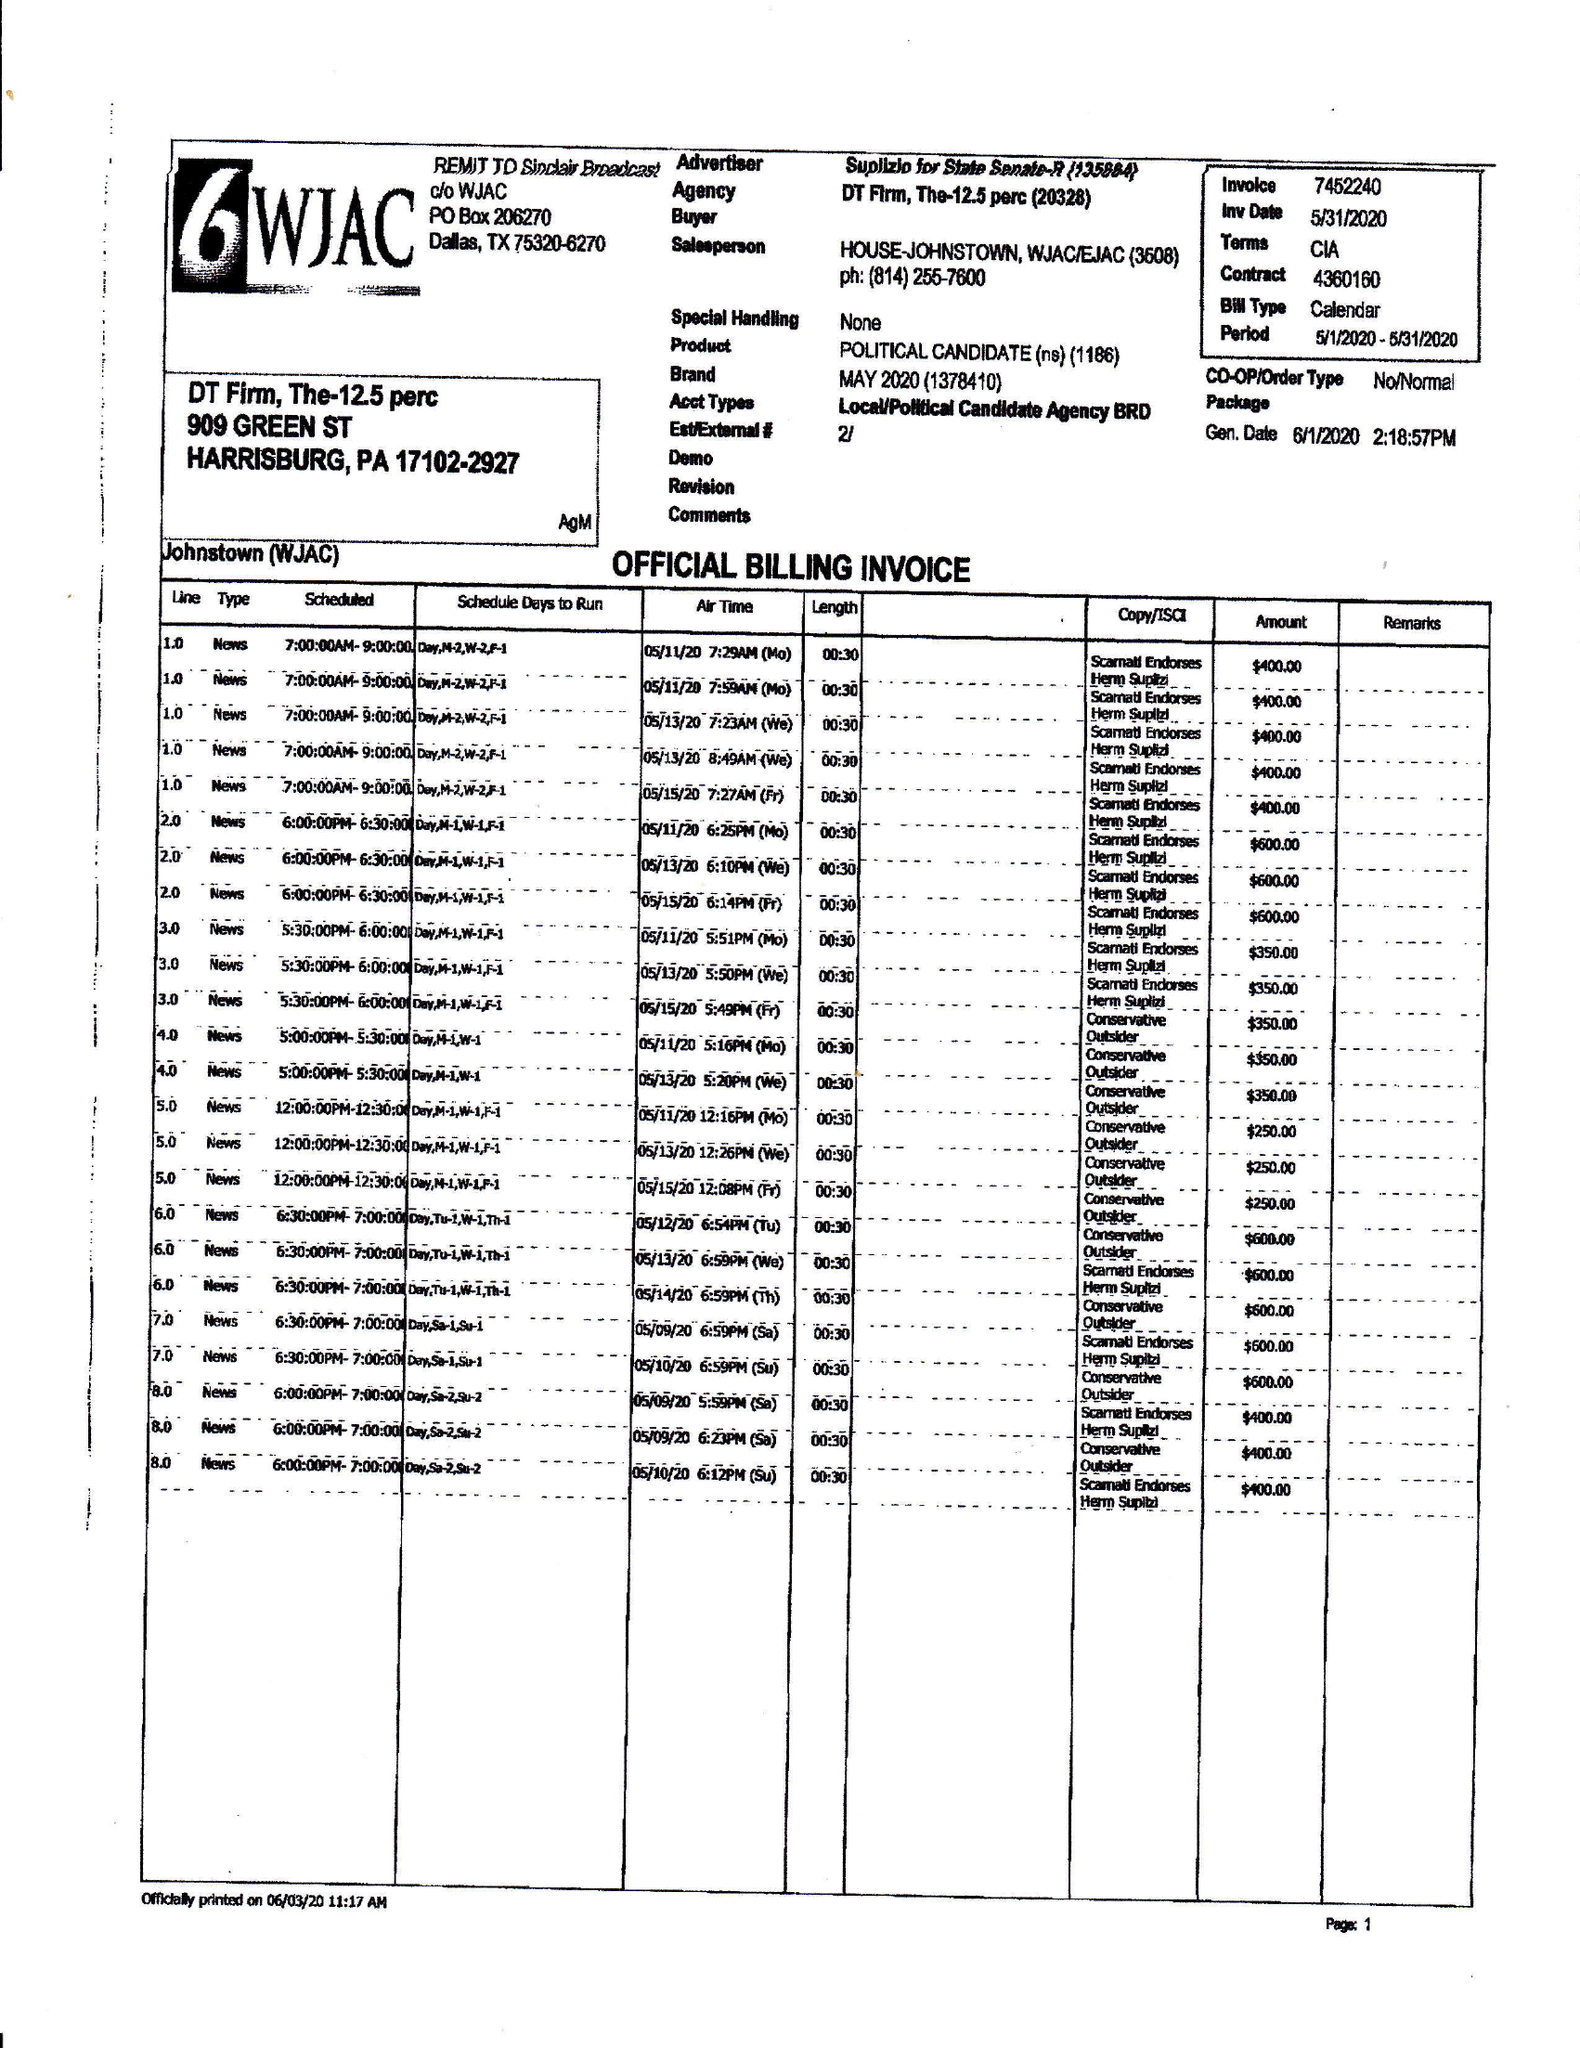What is the value for the flight_to?
Answer the question using a single word or phrase. 05/31/20 